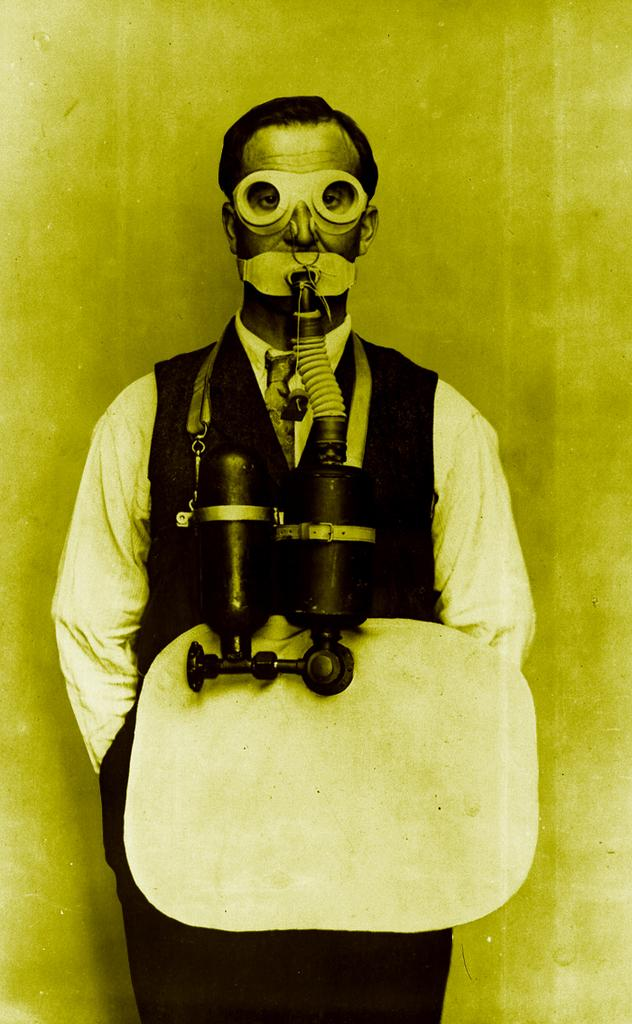Who is present in the image? There is a man in the image. What is the man wearing in the image? The man is wearing an oxygen cylinder in the image. What is the color of the background in the image? The background of the image is green. How many times does the man fold his arms in the image? There is no indication in the image that the man is folding his arms, so it cannot be determined from the picture. 